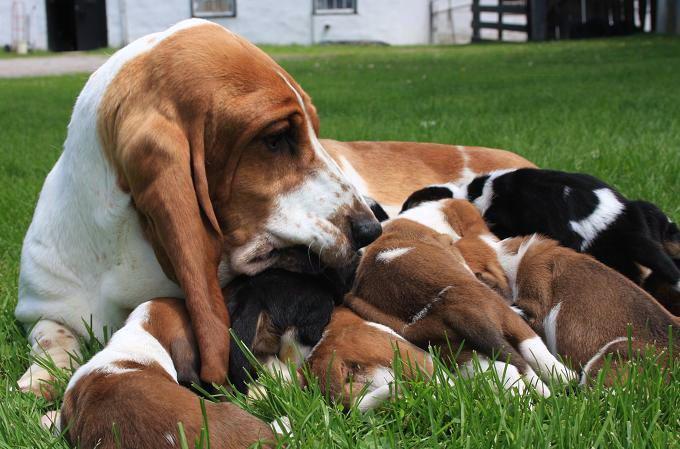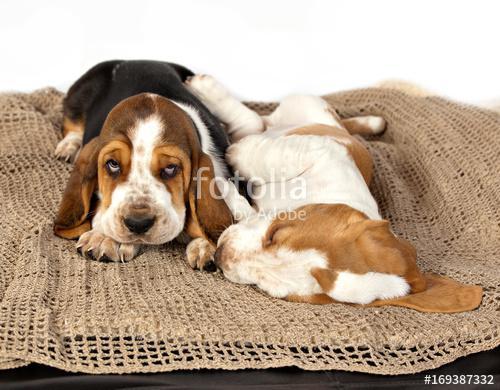The first image is the image on the left, the second image is the image on the right. Evaluate the accuracy of this statement regarding the images: "The dogs in the image on the right are outside in the grass.". Is it true? Answer yes or no. No. The first image is the image on the left, the second image is the image on the right. Assess this claim about the two images: "One image shows a large basset hound on green grass, with at least one smaller hound touching it, and the other image features exactly two hounds side-by-side.". Correct or not? Answer yes or no. Yes. 